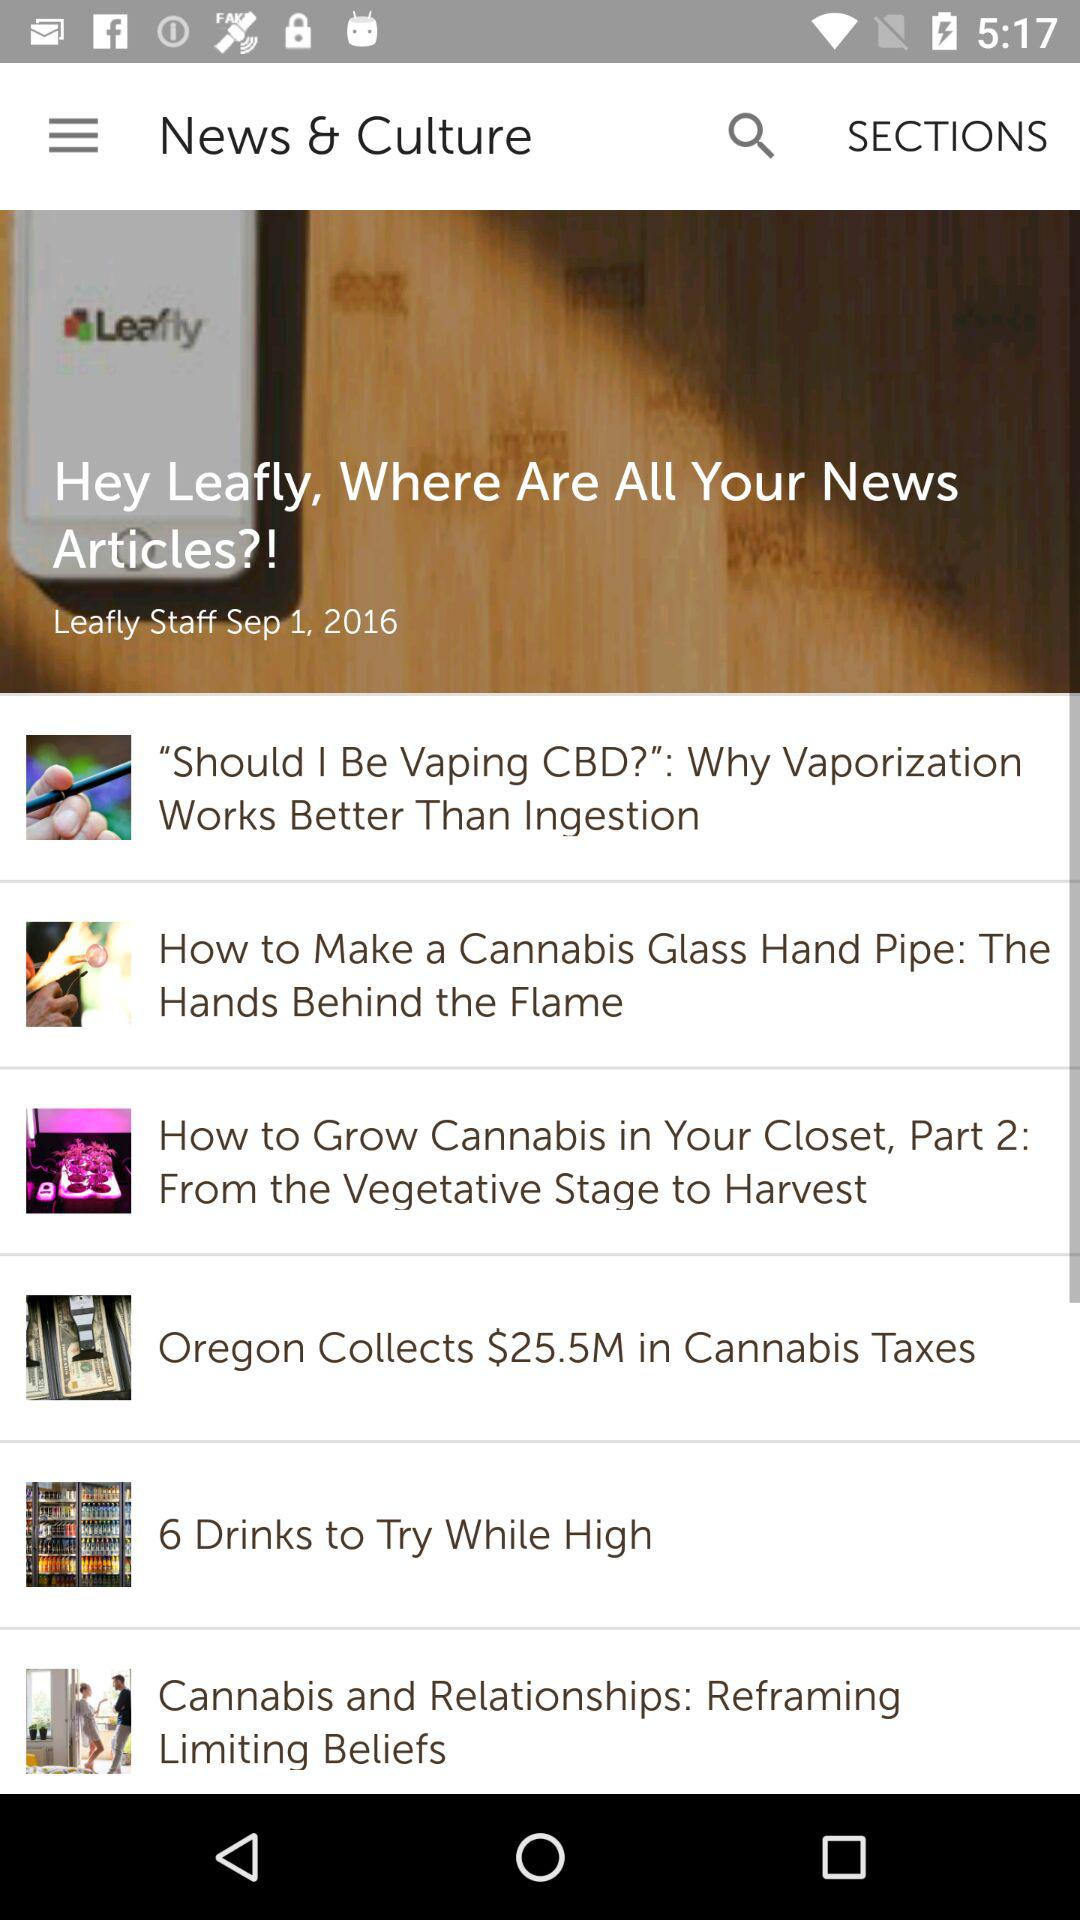What is the post-date of the article? The post-date of the article is September 1, 2016. 